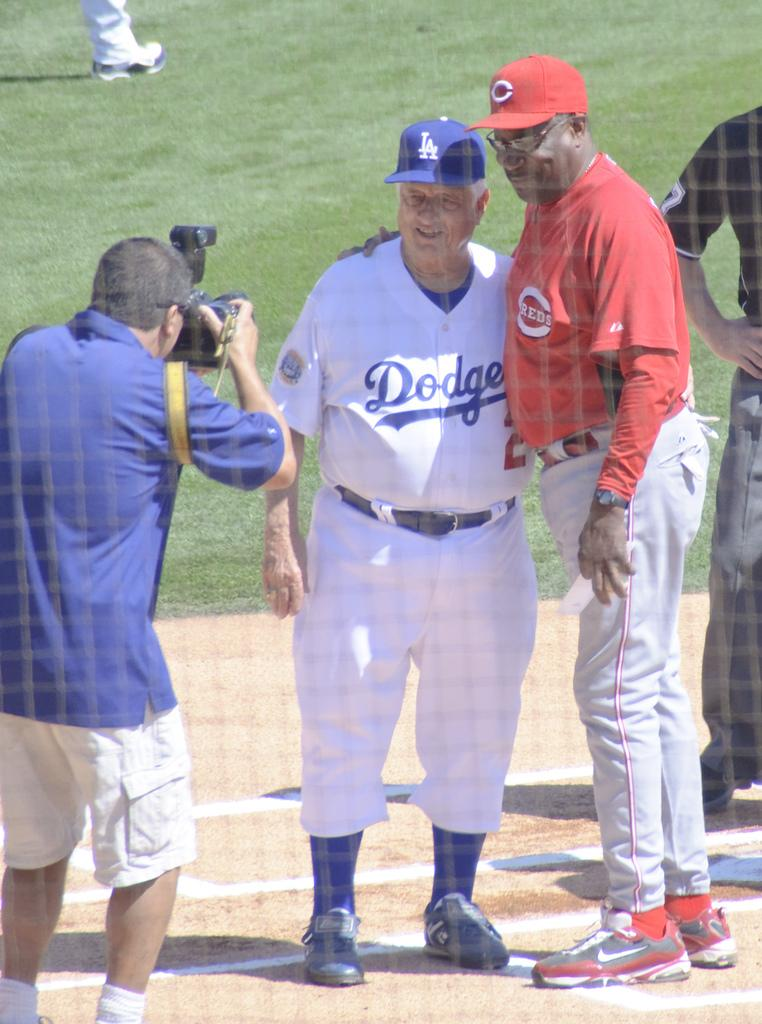<image>
Provide a brief description of the given image. Coaches from the LA Dodgers and Cincinatti Reds embrace each other for a photograph while standing near home plate. 